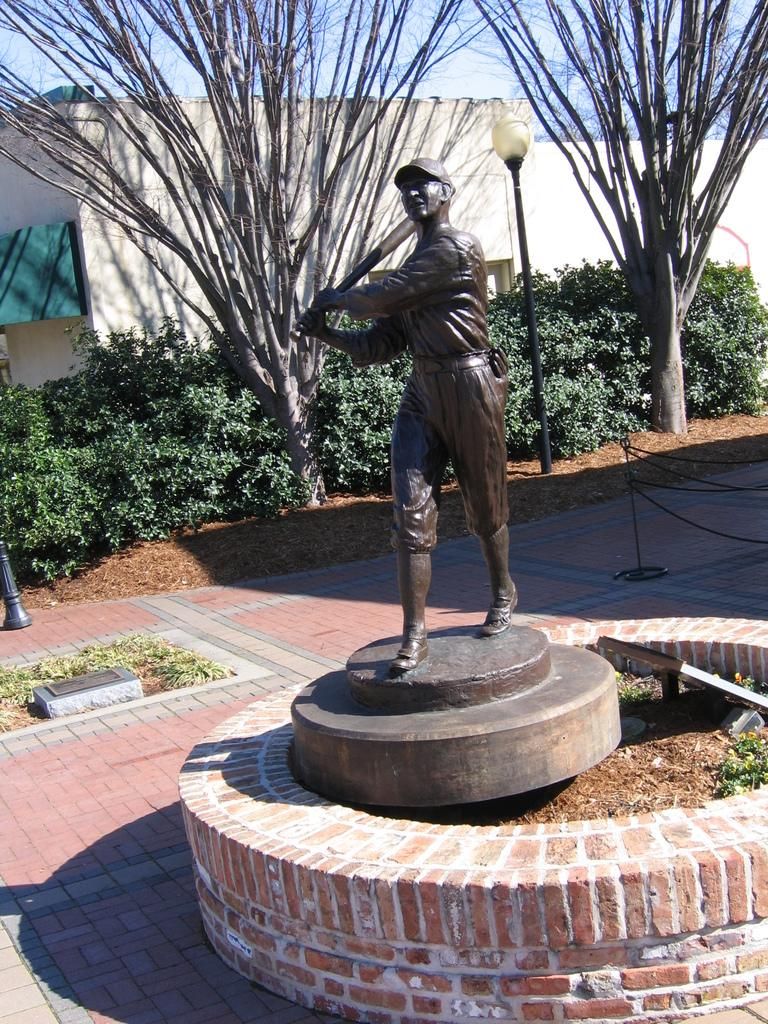What is the main subject in the image? There is a statue in the image. What can be seen in the background of the image? There are plants, a pole, trees, fencing, the sky, and a building visible in the background of the image. What type of horn can be seen on the statue in the image? There is no horn present on the statue in the image. 